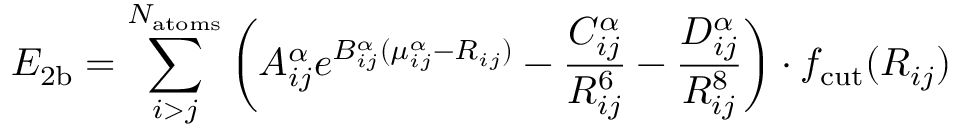<formula> <loc_0><loc_0><loc_500><loc_500>E _ { 2 b } = \sum _ { i > j } ^ { N _ { a t o m s } } \left ( A _ { i j } ^ { \alpha } e ^ { B _ { i j } ^ { \alpha } ( \mu _ { i j } ^ { \alpha } - R _ { i j } ) } - \frac { C _ { i j } ^ { \alpha } } { R _ { i j } ^ { 6 } } - \frac { D _ { i j } ^ { \alpha } } { R _ { i j } ^ { 8 } } \right ) \cdot f _ { c u t } ( R _ { i j } )</formula> 